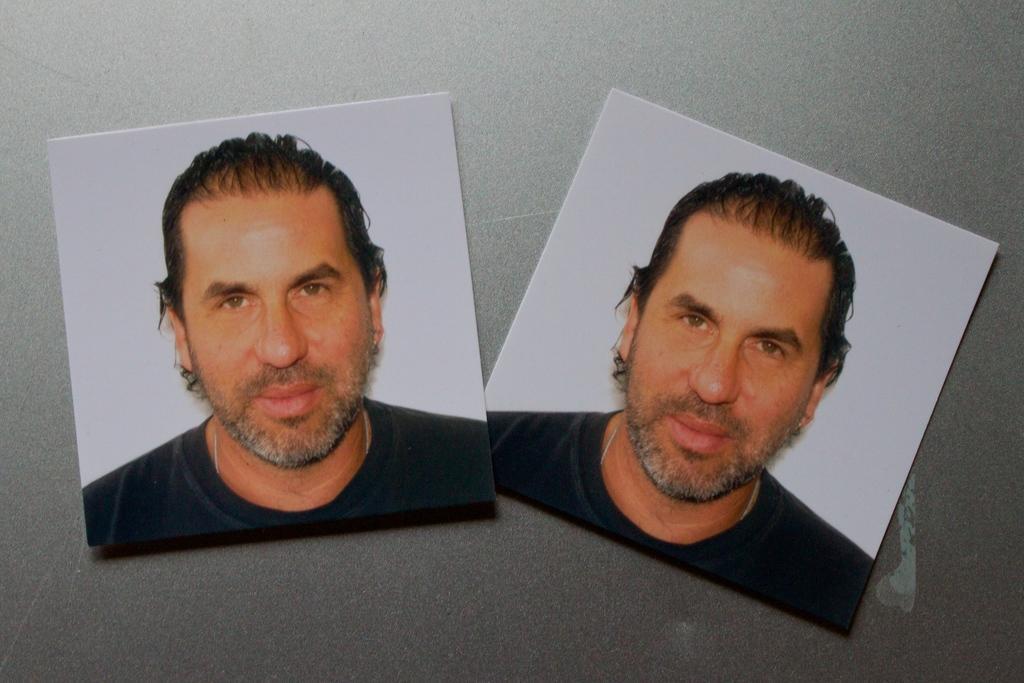Could you give a brief overview of what you see in this image? Here in this picture we can see a couple of photographs of a person present on a table and we can see the person is smiling. 